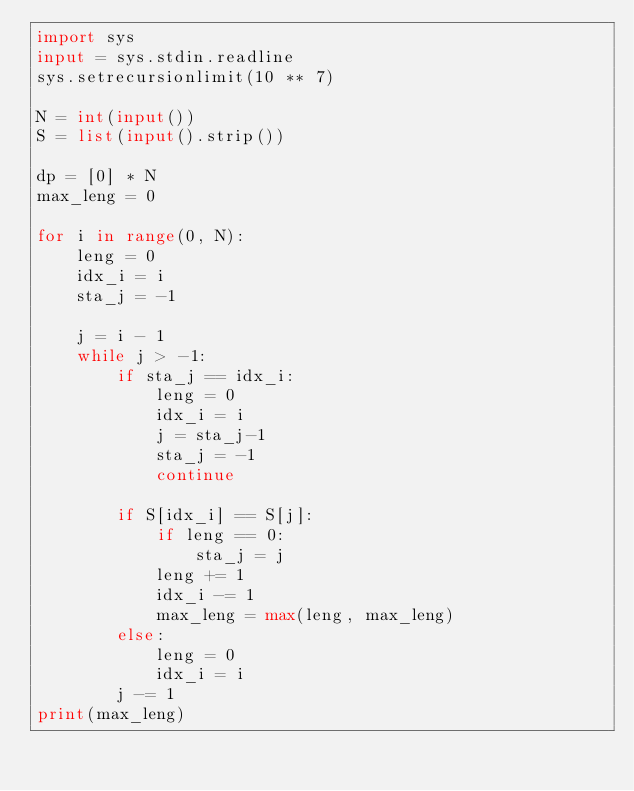Convert code to text. <code><loc_0><loc_0><loc_500><loc_500><_Python_>import sys
input = sys.stdin.readline
sys.setrecursionlimit(10 ** 7)

N = int(input())
S = list(input().strip())

dp = [0] * N
max_leng = 0

for i in range(0, N):
    leng = 0
    idx_i = i
    sta_j = -1

    j = i - 1
    while j > -1:
        if sta_j == idx_i:
            leng = 0
            idx_i = i
            j = sta_j-1
            sta_j = -1
            continue

        if S[idx_i] == S[j]:
            if leng == 0:
                sta_j = j
            leng += 1
            idx_i -= 1
            max_leng = max(leng, max_leng)
        else:
            leng = 0
            idx_i = i
        j -= 1
print(max_leng)</code> 